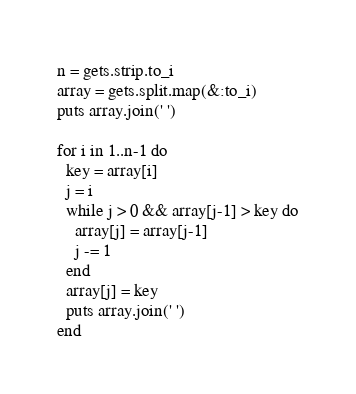<code> <loc_0><loc_0><loc_500><loc_500><_Ruby_>n = gets.strip.to_i
array = gets.split.map(&:to_i)
puts array.join(' ') 
 
for i in 1..n-1 do
  key = array[i]
  j = i
  while j > 0 && array[j-1] > key do
    array[j] = array[j-1]
    j -= 1
  end
  array[j] = key
  puts array.join(' ')
end</code> 